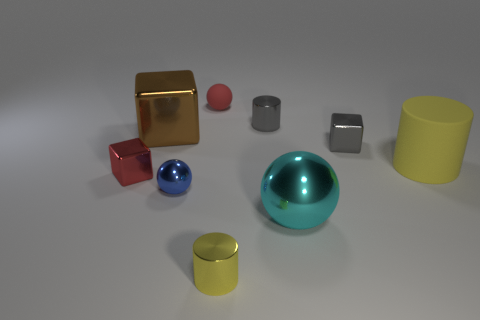What is the tiny cube that is to the right of the tiny red shiny object made of?
Keep it short and to the point. Metal. The cyan object that is the same shape as the blue metallic object is what size?
Make the answer very short. Large. Are there fewer tiny rubber spheres behind the tiny rubber object than large yellow spheres?
Offer a terse response. No. Are any big matte blocks visible?
Offer a very short reply. No. What color is the other tiny object that is the same shape as the small red matte object?
Ensure brevity in your answer.  Blue. Does the tiny thing that is left of the tiny blue sphere have the same color as the tiny matte thing?
Your answer should be very brief. Yes. Does the blue metal ball have the same size as the brown cube?
Offer a very short reply. No. There is a yellow thing that is made of the same material as the small blue ball; what shape is it?
Provide a succinct answer. Cylinder. How many other objects are there of the same shape as the big matte thing?
Offer a terse response. 2. There is a metal thing right of the ball to the right of the metal cylinder that is in front of the small red cube; what is its shape?
Provide a succinct answer. Cube. 